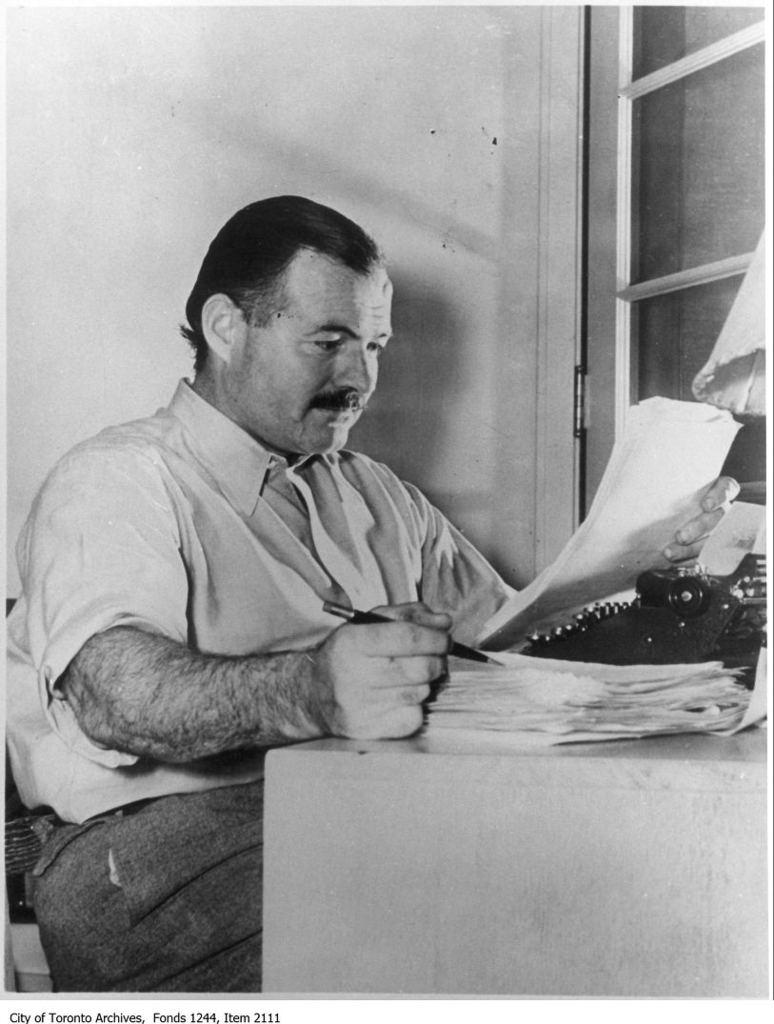What is the man in the image doing? The man is sitting in the image and holding a paper and pen. What might the man be using the paper and pen for? The man might be using the paper and pen for writing or taking notes. What is on the table in front of the man? There are papers and an object on the table in front of the man. What can be seen on the wall in the image? The information provided does not specify what can be seen on the wall. What is visible through the window in the image? The information provided does not specify what is visible through the window. What type of soup is being served in the image? There is no soup present in the image. How many horses can be seen in the image? There are no horses present in the image. 